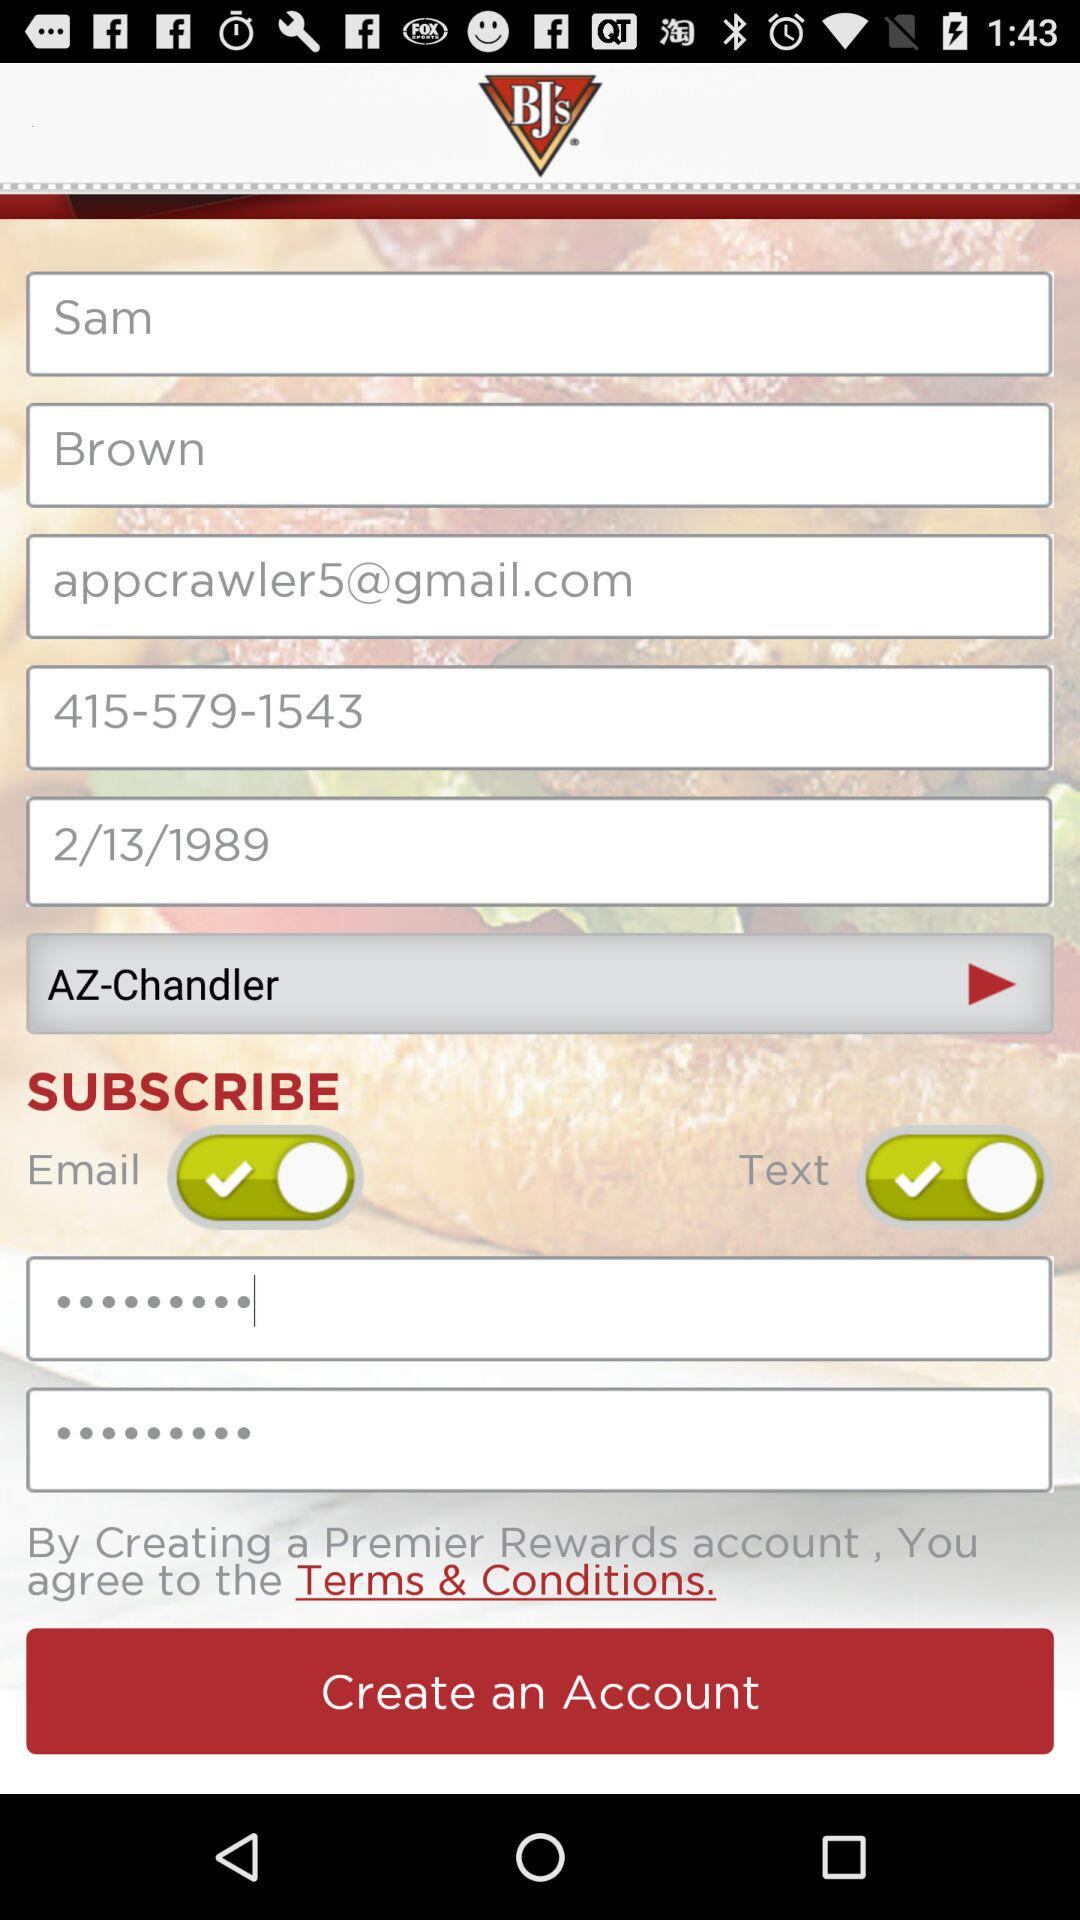What is the first name? The first name is Sam. 